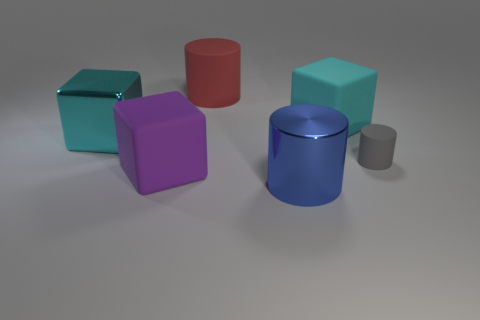Subtract all blue cylinders. How many cylinders are left? 2 Subtract all yellow cylinders. How many cyan cubes are left? 2 Add 1 blue things. How many objects exist? 7 Subtract 1 cylinders. How many cylinders are left? 2 Add 3 blue shiny objects. How many blue shiny objects are left? 4 Add 2 big purple cubes. How many big purple cubes exist? 3 Subtract 0 brown balls. How many objects are left? 6 Subtract all blue blocks. Subtract all yellow cylinders. How many blocks are left? 3 Subtract all brown metallic cubes. Subtract all gray cylinders. How many objects are left? 5 